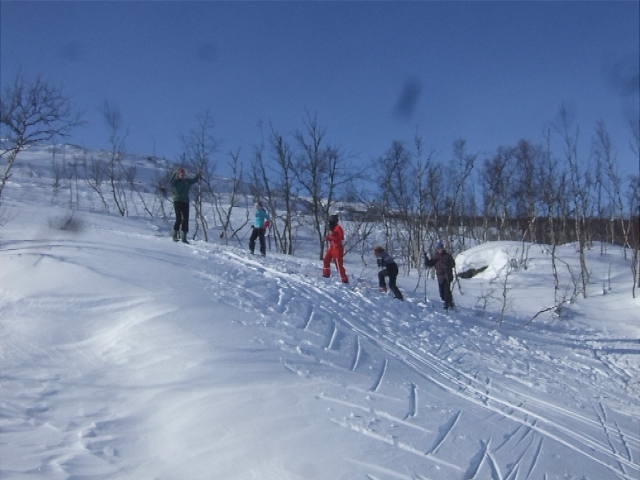Describe the objects in this image and their specific colors. I can see people in blue, black, gray, and darkblue tones, people in blue, maroon, purple, and black tones, people in blue, black, and gray tones, people in blue, black, gray, and darkblue tones, and people in blue, black, and gray tones in this image. 